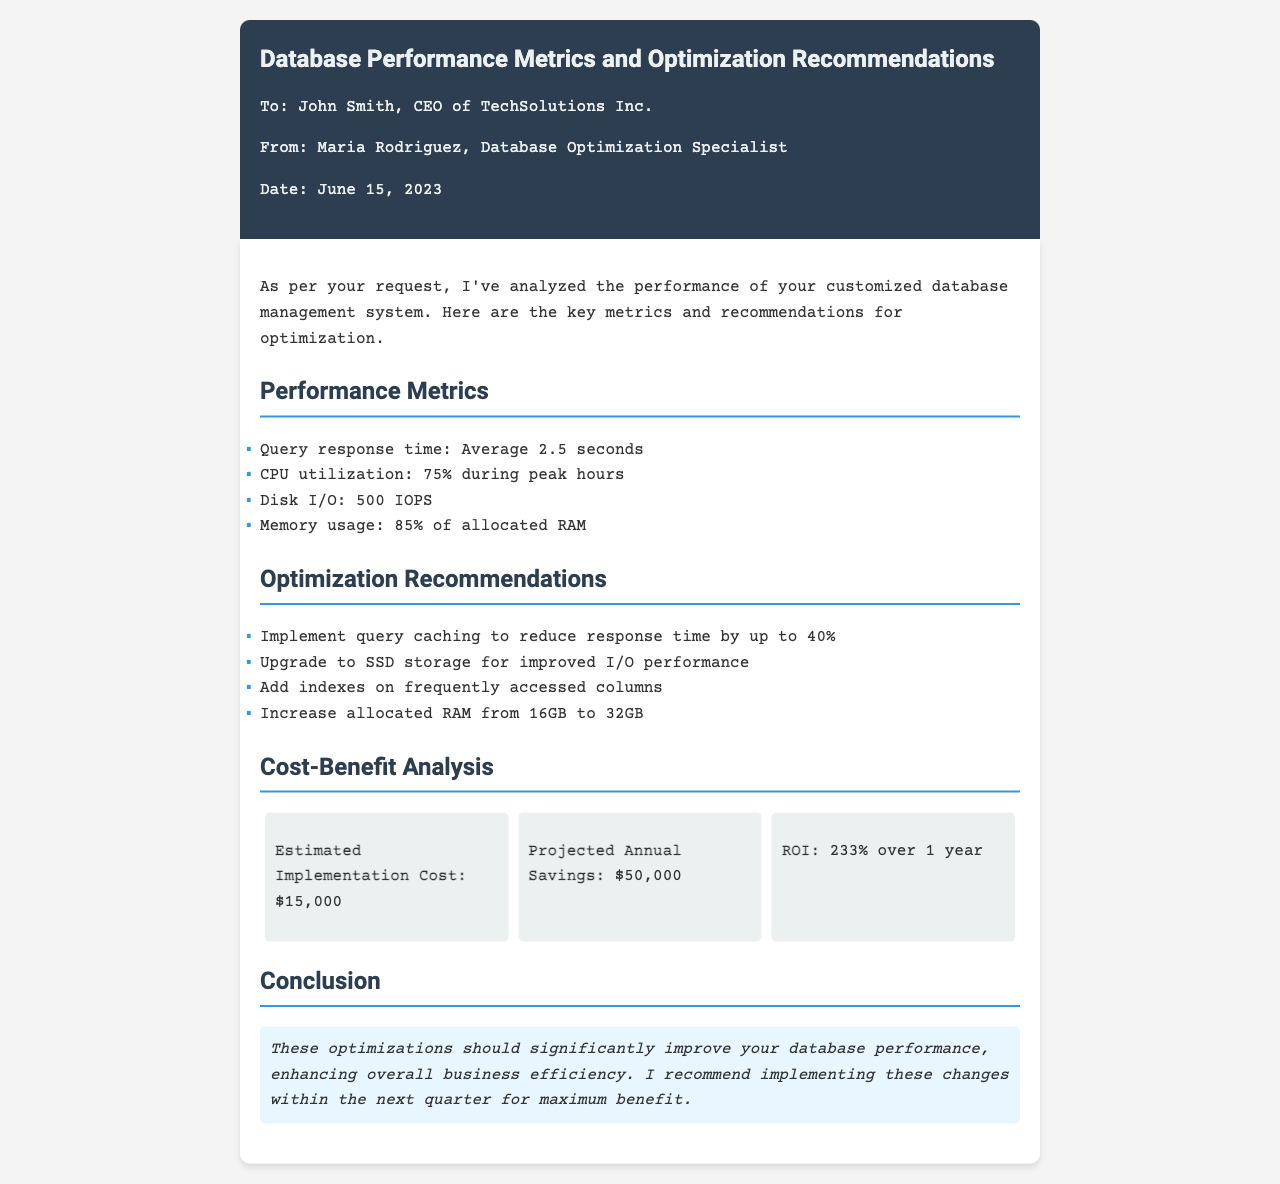What is the average query response time? The average query response time is explicitly stated in the document as 2.5 seconds.
Answer: 2.5 seconds What is the CPU utilization during peak hours? The document specifies that CPU utilization is 75% during peak hours.
Answer: 75% How much RAM is currently allocated? According to the document, the currently allocated RAM is 16GB.
Answer: 16GB What is the estimated implementation cost of the recommendations? The implementation cost is listed in the cost-benefit analysis section as $15,000.
Answer: $15,000 What is the projected annual savings after implementing the recommendations? The document indicates that the projected annual savings is $50,000.
Answer: $50,000 What is the ROI over one year? The ROI over one year is explicitly stated as 233%.
Answer: 233% What does the conclusion recommend regarding the timing of the changes? The conclusion recommends implementing these changes within the next quarter for maximum benefit.
Answer: within the next quarter What is one of the optimization recommendations for improving I/O performance? One recommendation for improving I/O performance is upgrading to SSD storage.
Answer: upgrading to SSD storage What is one way to reduce response time? The document suggests implementing query caching to reduce response time.
Answer: implementing query caching 